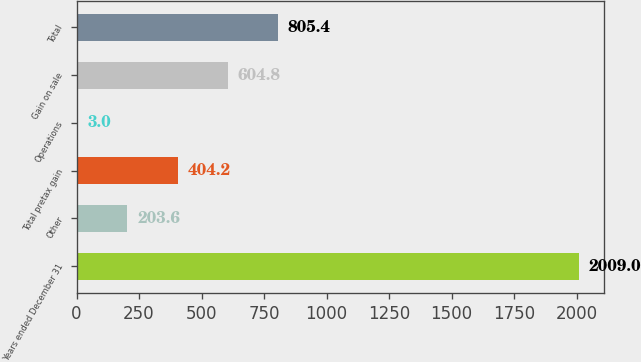Convert chart. <chart><loc_0><loc_0><loc_500><loc_500><bar_chart><fcel>Years ended December 31<fcel>Other<fcel>Total pretax gain<fcel>Operations<fcel>Gain on sale<fcel>Total<nl><fcel>2009<fcel>203.6<fcel>404.2<fcel>3<fcel>604.8<fcel>805.4<nl></chart> 